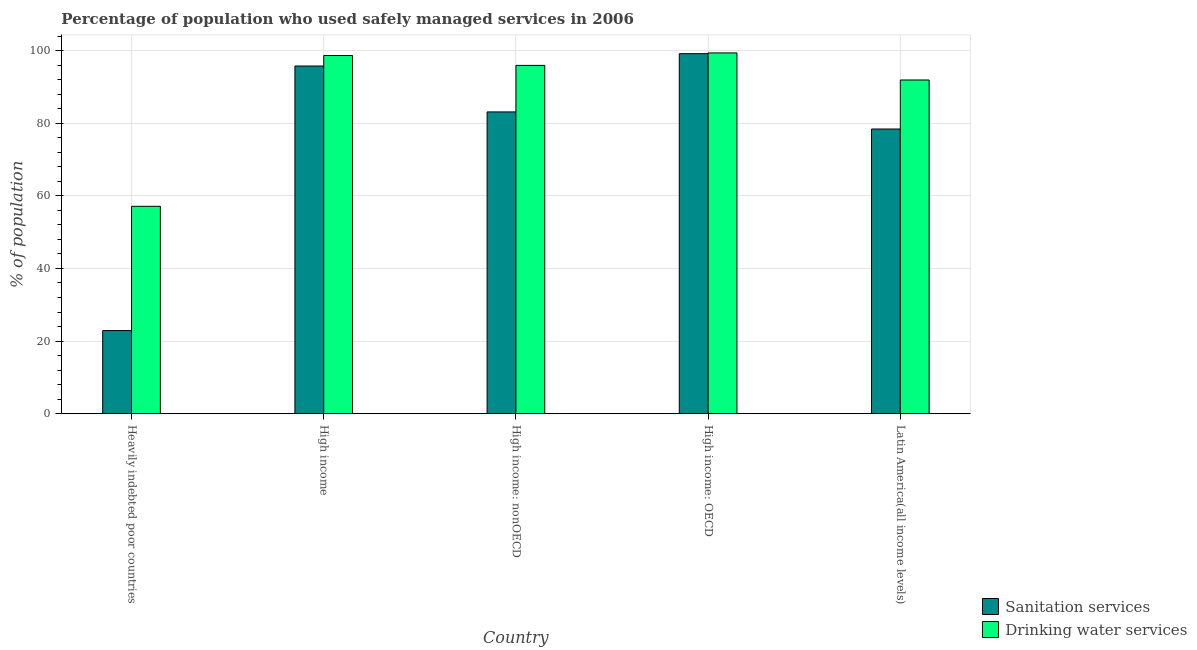How many groups of bars are there?
Give a very brief answer. 5. Are the number of bars on each tick of the X-axis equal?
Your response must be concise. Yes. What is the label of the 1st group of bars from the left?
Give a very brief answer. Heavily indebted poor countries. What is the percentage of population who used sanitation services in Latin America(all income levels)?
Provide a short and direct response. 78.4. Across all countries, what is the maximum percentage of population who used drinking water services?
Make the answer very short. 99.35. Across all countries, what is the minimum percentage of population who used sanitation services?
Provide a succinct answer. 22.89. In which country was the percentage of population who used sanitation services maximum?
Ensure brevity in your answer.  High income: OECD. In which country was the percentage of population who used sanitation services minimum?
Keep it short and to the point. Heavily indebted poor countries. What is the total percentage of population who used drinking water services in the graph?
Keep it short and to the point. 442.89. What is the difference between the percentage of population who used drinking water services in Heavily indebted poor countries and that in High income: OECD?
Your answer should be very brief. -42.24. What is the difference between the percentage of population who used drinking water services in High income: OECD and the percentage of population who used sanitation services in Latin America(all income levels)?
Give a very brief answer. 20.95. What is the average percentage of population who used sanitation services per country?
Ensure brevity in your answer.  75.85. What is the difference between the percentage of population who used drinking water services and percentage of population who used sanitation services in High income: nonOECD?
Your response must be concise. 12.8. In how many countries, is the percentage of population who used drinking water services greater than 16 %?
Your response must be concise. 5. What is the ratio of the percentage of population who used sanitation services in High income to that in High income: nonOECD?
Make the answer very short. 1.15. Is the percentage of population who used drinking water services in Heavily indebted poor countries less than that in High income?
Provide a succinct answer. Yes. What is the difference between the highest and the second highest percentage of population who used sanitation services?
Your answer should be compact. 3.39. What is the difference between the highest and the lowest percentage of population who used drinking water services?
Offer a very short reply. 42.24. Is the sum of the percentage of population who used sanitation services in High income: OECD and High income: nonOECD greater than the maximum percentage of population who used drinking water services across all countries?
Give a very brief answer. Yes. What does the 1st bar from the left in Latin America(all income levels) represents?
Your answer should be compact. Sanitation services. What does the 1st bar from the right in High income represents?
Provide a succinct answer. Drinking water services. Are all the bars in the graph horizontal?
Provide a succinct answer. No. How many countries are there in the graph?
Provide a succinct answer. 5. How many legend labels are there?
Give a very brief answer. 2. What is the title of the graph?
Offer a terse response. Percentage of population who used safely managed services in 2006. Does "Rural Population" appear as one of the legend labels in the graph?
Provide a short and direct response. No. What is the label or title of the Y-axis?
Make the answer very short. % of population. What is the % of population in Sanitation services in Heavily indebted poor countries?
Give a very brief answer. 22.89. What is the % of population in Drinking water services in Heavily indebted poor countries?
Make the answer very short. 57.11. What is the % of population of Sanitation services in High income?
Ensure brevity in your answer.  95.74. What is the % of population in Drinking water services in High income?
Provide a short and direct response. 98.63. What is the % of population in Sanitation services in High income: nonOECD?
Make the answer very short. 83.1. What is the % of population in Drinking water services in High income: nonOECD?
Offer a terse response. 95.91. What is the % of population in Sanitation services in High income: OECD?
Make the answer very short. 99.14. What is the % of population of Drinking water services in High income: OECD?
Offer a very short reply. 99.35. What is the % of population of Sanitation services in Latin America(all income levels)?
Provide a short and direct response. 78.4. What is the % of population of Drinking water services in Latin America(all income levels)?
Your answer should be very brief. 91.89. Across all countries, what is the maximum % of population in Sanitation services?
Your answer should be very brief. 99.14. Across all countries, what is the maximum % of population of Drinking water services?
Give a very brief answer. 99.35. Across all countries, what is the minimum % of population of Sanitation services?
Your response must be concise. 22.89. Across all countries, what is the minimum % of population in Drinking water services?
Provide a short and direct response. 57.11. What is the total % of population in Sanitation services in the graph?
Give a very brief answer. 379.27. What is the total % of population in Drinking water services in the graph?
Ensure brevity in your answer.  442.89. What is the difference between the % of population in Sanitation services in Heavily indebted poor countries and that in High income?
Offer a terse response. -72.85. What is the difference between the % of population in Drinking water services in Heavily indebted poor countries and that in High income?
Offer a terse response. -41.52. What is the difference between the % of population in Sanitation services in Heavily indebted poor countries and that in High income: nonOECD?
Your response must be concise. -60.21. What is the difference between the % of population of Drinking water services in Heavily indebted poor countries and that in High income: nonOECD?
Keep it short and to the point. -38.8. What is the difference between the % of population in Sanitation services in Heavily indebted poor countries and that in High income: OECD?
Your answer should be compact. -76.24. What is the difference between the % of population in Drinking water services in Heavily indebted poor countries and that in High income: OECD?
Offer a very short reply. -42.24. What is the difference between the % of population of Sanitation services in Heavily indebted poor countries and that in Latin America(all income levels)?
Ensure brevity in your answer.  -55.5. What is the difference between the % of population in Drinking water services in Heavily indebted poor countries and that in Latin America(all income levels)?
Make the answer very short. -34.78. What is the difference between the % of population in Sanitation services in High income and that in High income: nonOECD?
Provide a short and direct response. 12.64. What is the difference between the % of population of Drinking water services in High income and that in High income: nonOECD?
Your response must be concise. 2.72. What is the difference between the % of population in Sanitation services in High income and that in High income: OECD?
Offer a very short reply. -3.39. What is the difference between the % of population of Drinking water services in High income and that in High income: OECD?
Provide a short and direct response. -0.72. What is the difference between the % of population of Sanitation services in High income and that in Latin America(all income levels)?
Ensure brevity in your answer.  17.35. What is the difference between the % of population of Drinking water services in High income and that in Latin America(all income levels)?
Make the answer very short. 6.74. What is the difference between the % of population of Sanitation services in High income: nonOECD and that in High income: OECD?
Provide a succinct answer. -16.03. What is the difference between the % of population of Drinking water services in High income: nonOECD and that in High income: OECD?
Your answer should be very brief. -3.44. What is the difference between the % of population in Sanitation services in High income: nonOECD and that in Latin America(all income levels)?
Ensure brevity in your answer.  4.71. What is the difference between the % of population of Drinking water services in High income: nonOECD and that in Latin America(all income levels)?
Offer a very short reply. 4.02. What is the difference between the % of population in Sanitation services in High income: OECD and that in Latin America(all income levels)?
Provide a succinct answer. 20.74. What is the difference between the % of population in Drinking water services in High income: OECD and that in Latin America(all income levels)?
Give a very brief answer. 7.45. What is the difference between the % of population of Sanitation services in Heavily indebted poor countries and the % of population of Drinking water services in High income?
Provide a succinct answer. -75.74. What is the difference between the % of population in Sanitation services in Heavily indebted poor countries and the % of population in Drinking water services in High income: nonOECD?
Give a very brief answer. -73.02. What is the difference between the % of population of Sanitation services in Heavily indebted poor countries and the % of population of Drinking water services in High income: OECD?
Your answer should be very brief. -76.45. What is the difference between the % of population of Sanitation services in Heavily indebted poor countries and the % of population of Drinking water services in Latin America(all income levels)?
Your answer should be very brief. -69. What is the difference between the % of population in Sanitation services in High income and the % of population in Drinking water services in High income: nonOECD?
Make the answer very short. -0.16. What is the difference between the % of population of Sanitation services in High income and the % of population of Drinking water services in High income: OECD?
Your answer should be compact. -3.6. What is the difference between the % of population of Sanitation services in High income and the % of population of Drinking water services in Latin America(all income levels)?
Your answer should be compact. 3.85. What is the difference between the % of population of Sanitation services in High income: nonOECD and the % of population of Drinking water services in High income: OECD?
Provide a succinct answer. -16.24. What is the difference between the % of population of Sanitation services in High income: nonOECD and the % of population of Drinking water services in Latin America(all income levels)?
Ensure brevity in your answer.  -8.79. What is the difference between the % of population in Sanitation services in High income: OECD and the % of population in Drinking water services in Latin America(all income levels)?
Your answer should be compact. 7.24. What is the average % of population in Sanitation services per country?
Your answer should be very brief. 75.85. What is the average % of population of Drinking water services per country?
Make the answer very short. 88.58. What is the difference between the % of population of Sanitation services and % of population of Drinking water services in Heavily indebted poor countries?
Ensure brevity in your answer.  -34.22. What is the difference between the % of population in Sanitation services and % of population in Drinking water services in High income?
Provide a succinct answer. -2.89. What is the difference between the % of population of Sanitation services and % of population of Drinking water services in High income: nonOECD?
Give a very brief answer. -12.8. What is the difference between the % of population of Sanitation services and % of population of Drinking water services in High income: OECD?
Provide a short and direct response. -0.21. What is the difference between the % of population in Sanitation services and % of population in Drinking water services in Latin America(all income levels)?
Ensure brevity in your answer.  -13.5. What is the ratio of the % of population of Sanitation services in Heavily indebted poor countries to that in High income?
Ensure brevity in your answer.  0.24. What is the ratio of the % of population of Drinking water services in Heavily indebted poor countries to that in High income?
Offer a very short reply. 0.58. What is the ratio of the % of population of Sanitation services in Heavily indebted poor countries to that in High income: nonOECD?
Keep it short and to the point. 0.28. What is the ratio of the % of population in Drinking water services in Heavily indebted poor countries to that in High income: nonOECD?
Your answer should be very brief. 0.6. What is the ratio of the % of population in Sanitation services in Heavily indebted poor countries to that in High income: OECD?
Make the answer very short. 0.23. What is the ratio of the % of population in Drinking water services in Heavily indebted poor countries to that in High income: OECD?
Provide a succinct answer. 0.57. What is the ratio of the % of population of Sanitation services in Heavily indebted poor countries to that in Latin America(all income levels)?
Your answer should be very brief. 0.29. What is the ratio of the % of population in Drinking water services in Heavily indebted poor countries to that in Latin America(all income levels)?
Your answer should be very brief. 0.62. What is the ratio of the % of population of Sanitation services in High income to that in High income: nonOECD?
Offer a very short reply. 1.15. What is the ratio of the % of population in Drinking water services in High income to that in High income: nonOECD?
Provide a succinct answer. 1.03. What is the ratio of the % of population of Sanitation services in High income to that in High income: OECD?
Your answer should be compact. 0.97. What is the ratio of the % of population in Drinking water services in High income to that in High income: OECD?
Give a very brief answer. 0.99. What is the ratio of the % of population of Sanitation services in High income to that in Latin America(all income levels)?
Keep it short and to the point. 1.22. What is the ratio of the % of population in Drinking water services in High income to that in Latin America(all income levels)?
Your response must be concise. 1.07. What is the ratio of the % of population of Sanitation services in High income: nonOECD to that in High income: OECD?
Offer a terse response. 0.84. What is the ratio of the % of population of Drinking water services in High income: nonOECD to that in High income: OECD?
Provide a succinct answer. 0.97. What is the ratio of the % of population of Sanitation services in High income: nonOECD to that in Latin America(all income levels)?
Your answer should be very brief. 1.06. What is the ratio of the % of population in Drinking water services in High income: nonOECD to that in Latin America(all income levels)?
Ensure brevity in your answer.  1.04. What is the ratio of the % of population of Sanitation services in High income: OECD to that in Latin America(all income levels)?
Give a very brief answer. 1.26. What is the ratio of the % of population of Drinking water services in High income: OECD to that in Latin America(all income levels)?
Your answer should be compact. 1.08. What is the difference between the highest and the second highest % of population of Sanitation services?
Offer a terse response. 3.39. What is the difference between the highest and the second highest % of population in Drinking water services?
Provide a short and direct response. 0.72. What is the difference between the highest and the lowest % of population of Sanitation services?
Keep it short and to the point. 76.24. What is the difference between the highest and the lowest % of population in Drinking water services?
Your answer should be compact. 42.24. 